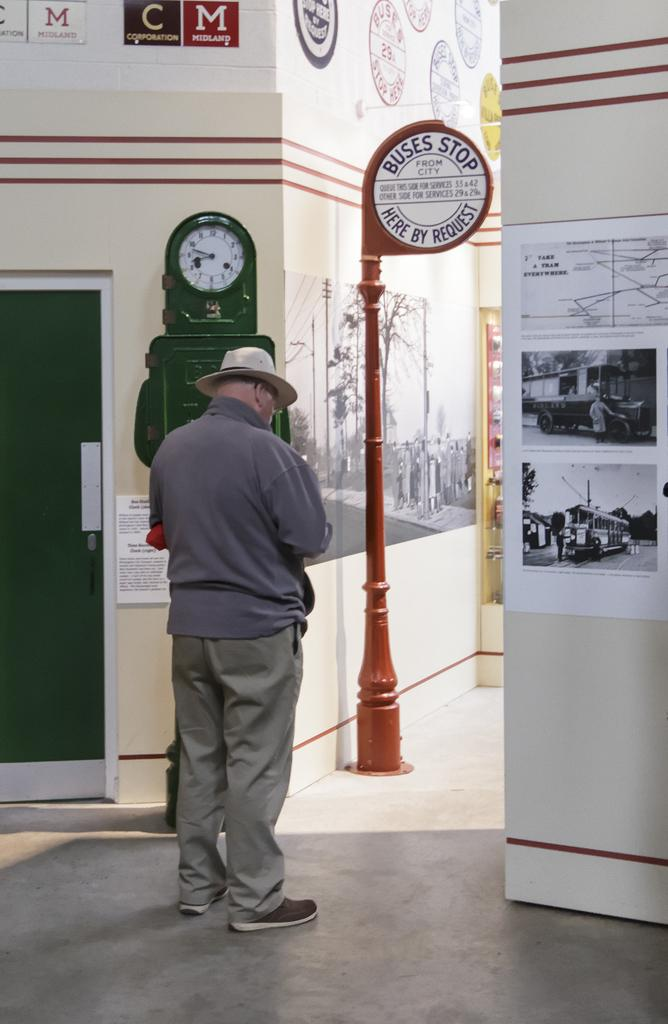<image>
Give a short and clear explanation of the subsequent image. An older man in front of a sign that says Buses stop here by request. 